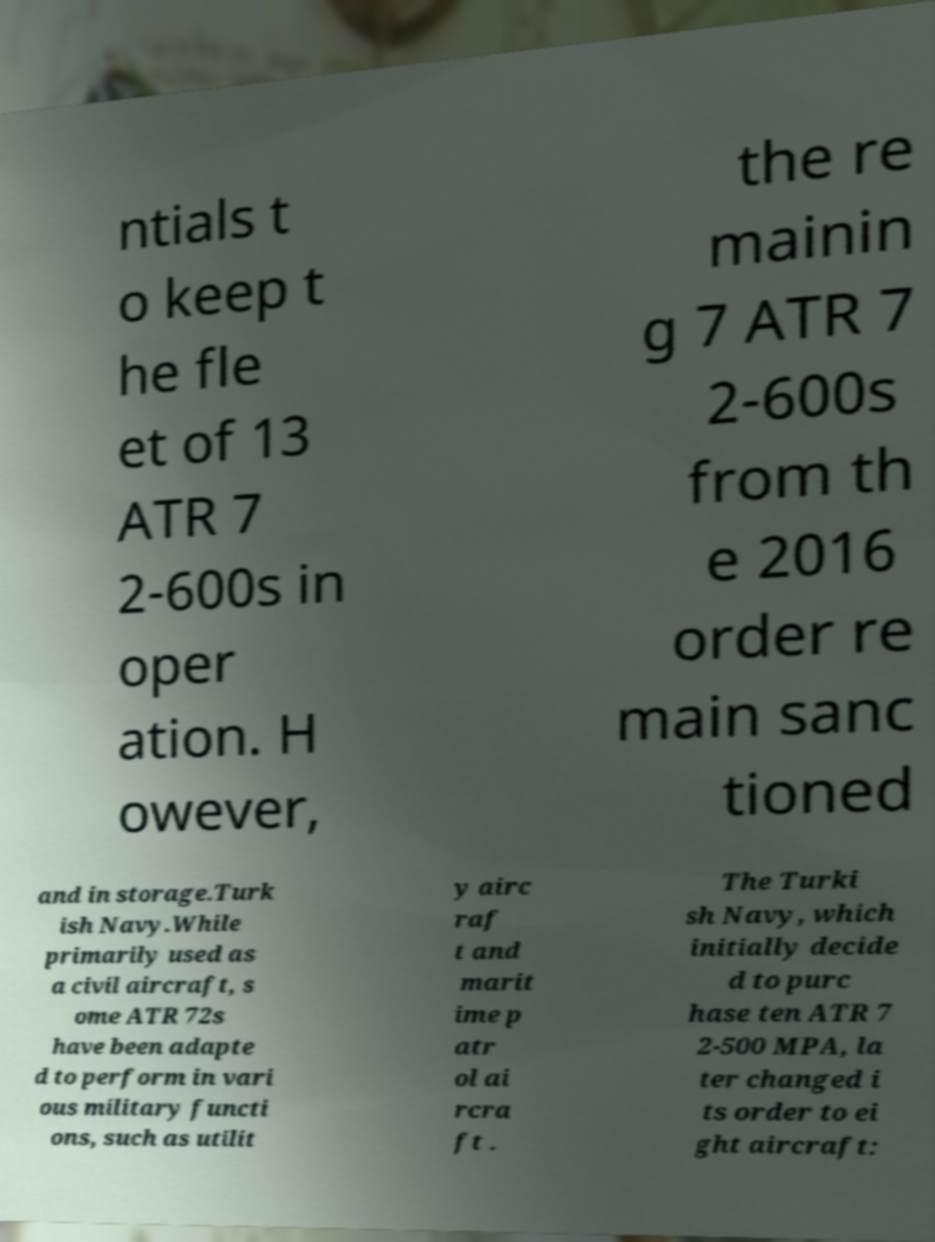For documentation purposes, I need the text within this image transcribed. Could you provide that? ntials t o keep t he fle et of 13 ATR 7 2-600s in oper ation. H owever, the re mainin g 7 ATR 7 2-600s from th e 2016 order re main sanc tioned and in storage.Turk ish Navy.While primarily used as a civil aircraft, s ome ATR 72s have been adapte d to perform in vari ous military functi ons, such as utilit y airc raf t and marit ime p atr ol ai rcra ft . The Turki sh Navy, which initially decide d to purc hase ten ATR 7 2-500 MPA, la ter changed i ts order to ei ght aircraft: 